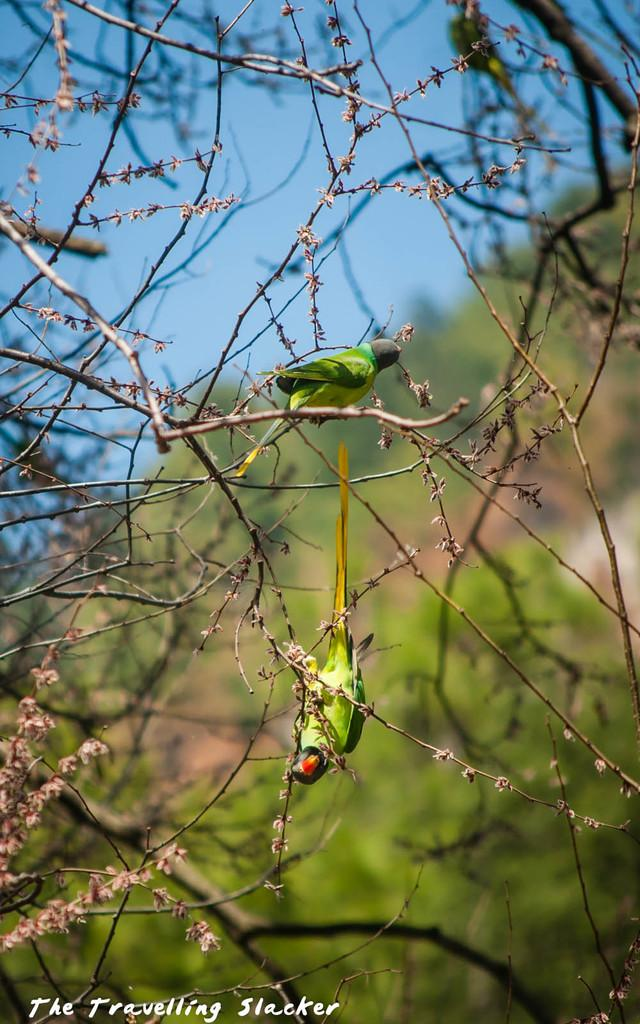How many parrots are in the image? There are two parrots in the image. Where are the parrots located? The parrots are on the branch of a tree. What can be seen in the background of the image? There are trees and the sky visible in the background of the image. What type of trouble are the fairies causing in the image? There are no fairies present in the image, so it is not possible to determine if they are causing any trouble. 